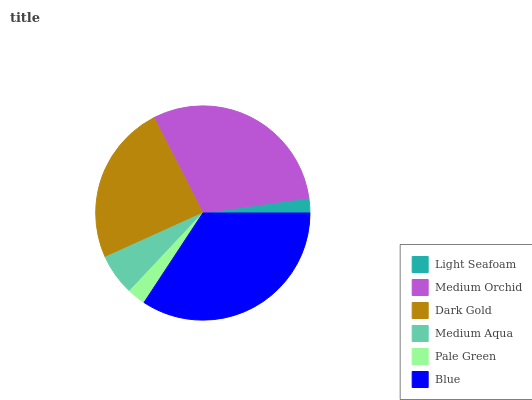Is Light Seafoam the minimum?
Answer yes or no. Yes. Is Blue the maximum?
Answer yes or no. Yes. Is Medium Orchid the minimum?
Answer yes or no. No. Is Medium Orchid the maximum?
Answer yes or no. No. Is Medium Orchid greater than Light Seafoam?
Answer yes or no. Yes. Is Light Seafoam less than Medium Orchid?
Answer yes or no. Yes. Is Light Seafoam greater than Medium Orchid?
Answer yes or no. No. Is Medium Orchid less than Light Seafoam?
Answer yes or no. No. Is Dark Gold the high median?
Answer yes or no. Yes. Is Medium Aqua the low median?
Answer yes or no. Yes. Is Light Seafoam the high median?
Answer yes or no. No. Is Pale Green the low median?
Answer yes or no. No. 